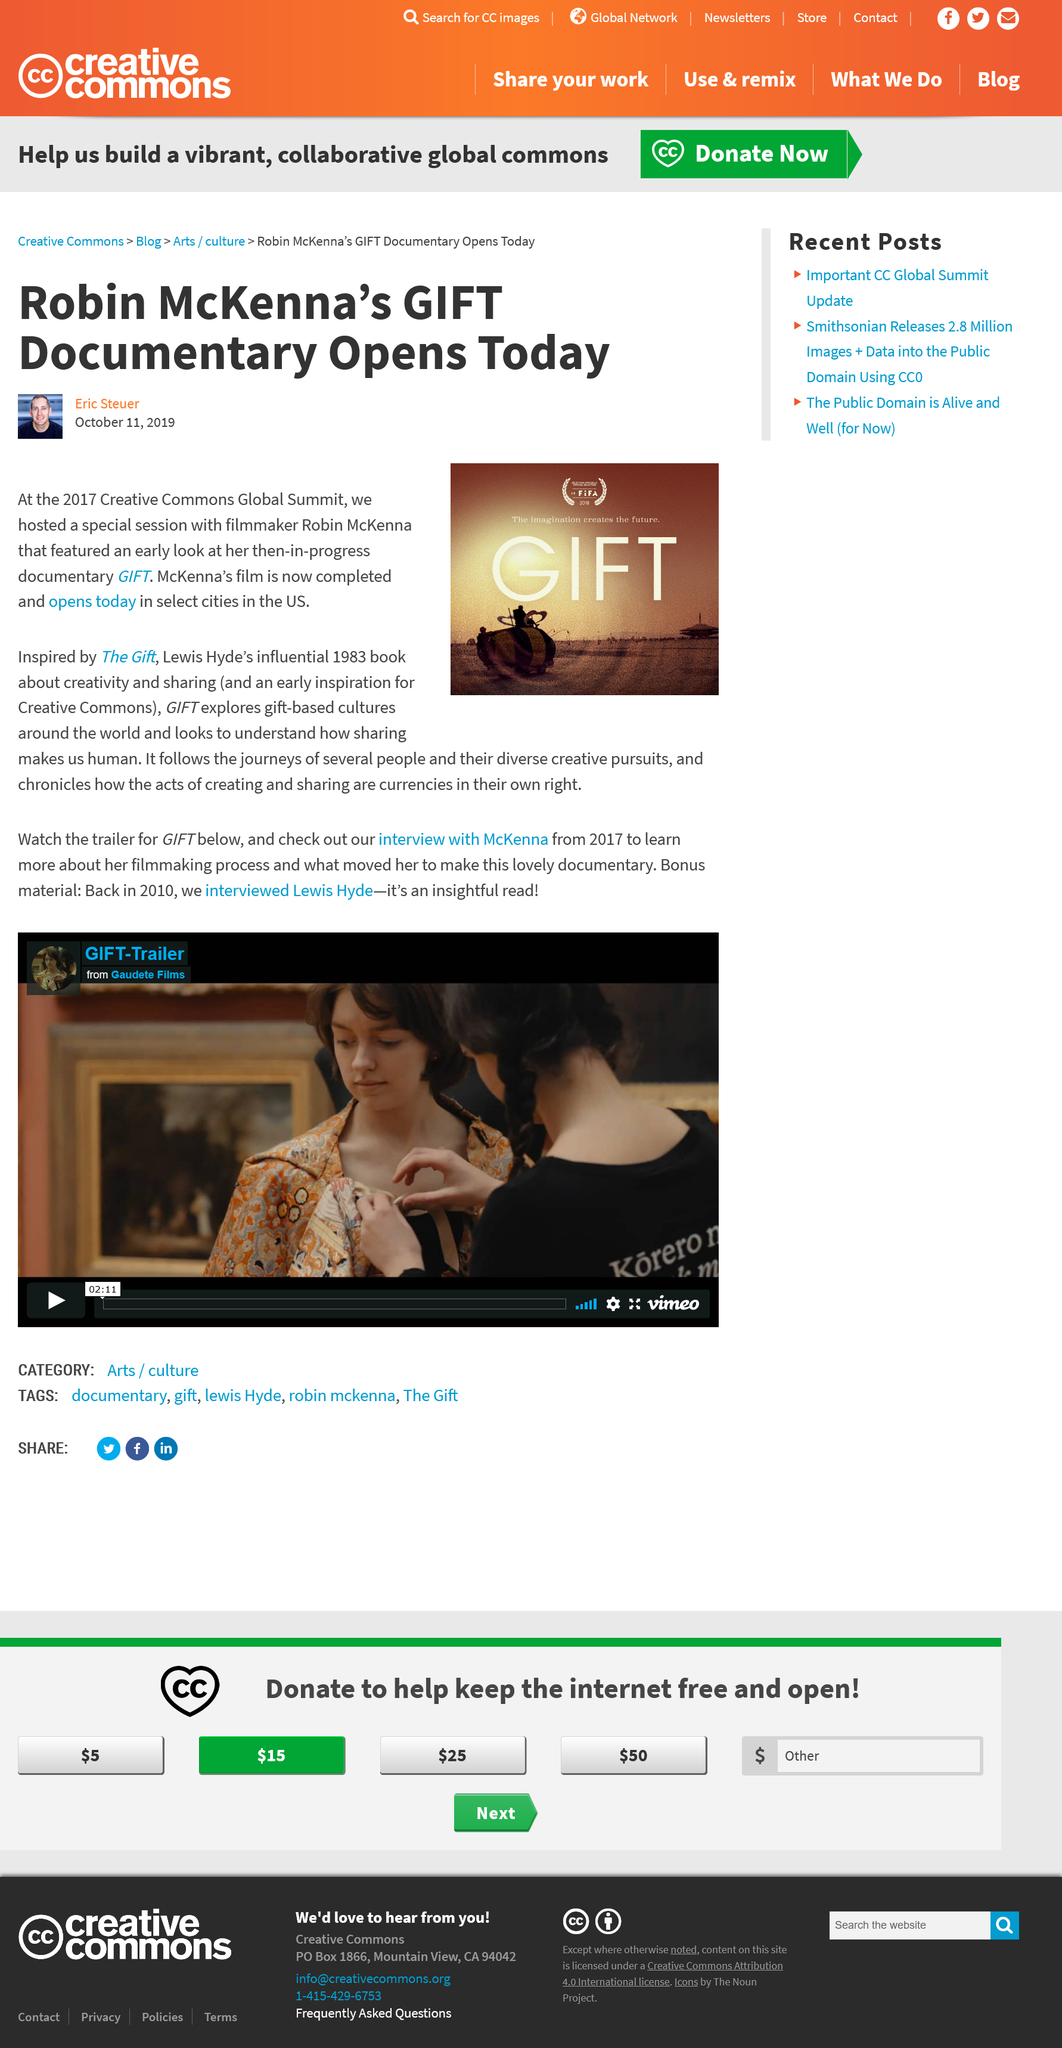Specify some key components in this picture. The finished film was not shown at the 2017 Creative Commons Global Summit, only a work-in-progress early preview was shown. The documentary is inspired by the book 'The Gift' by Lewis Hyde, which is the source of inspiration for the documentary. The film opens in the United States. 